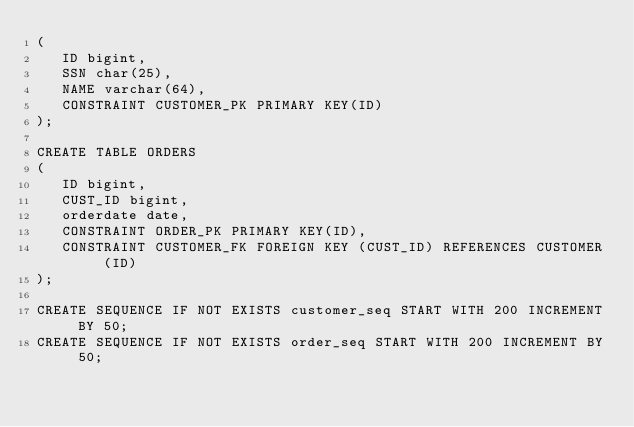Convert code to text. <code><loc_0><loc_0><loc_500><loc_500><_SQL_>(
   ID bigint,
   SSN char(25),
   NAME varchar(64),
   CONSTRAINT CUSTOMER_PK PRIMARY KEY(ID)
);

CREATE TABLE ORDERS
(
   ID bigint,
   CUST_ID bigint,
   orderdate date,
   CONSTRAINT ORDER_PK PRIMARY KEY(ID),
   CONSTRAINT CUSTOMER_FK FOREIGN KEY (CUST_ID) REFERENCES CUSTOMER (ID)
);

CREATE SEQUENCE IF NOT EXISTS customer_seq START WITH 200 INCREMENT BY 50;
CREATE SEQUENCE IF NOT EXISTS order_seq START WITH 200 INCREMENT BY 50;
</code> 